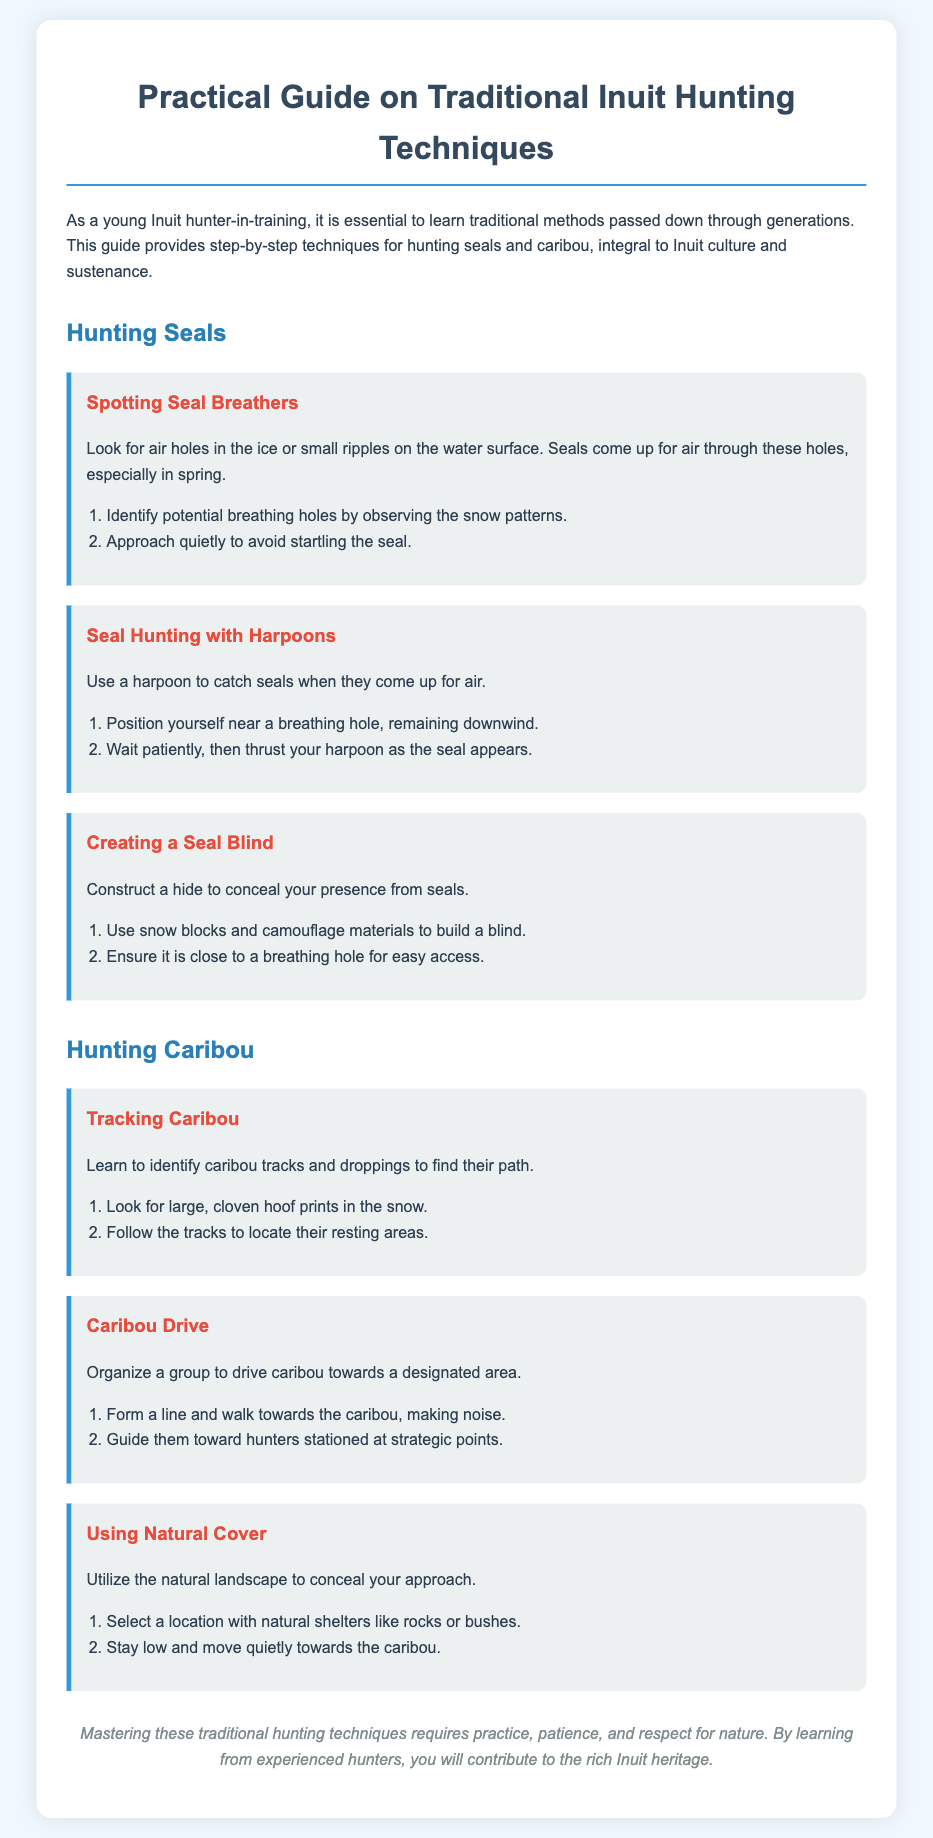What are the three techniques for hunting seals? The document lists three techniques: Spotting Seal Breathers, Seal Hunting with Harpoons, and Creating a Seal Blind.
Answer: Spotting Seal Breathers, Seal Hunting with Harpoons, Creating a Seal Blind How do you track caribou? To track caribou, one must look for large, cloven hoof prints in the snow and follow the tracks to locate their resting areas.
Answer: Look for large, cloven hoof prints What is used to catch seals when they come up for air? The document specifies that a harpoon is used to catch seals.
Answer: Harpoon What is the first step in creating a seal blind? The first step is to use snow blocks and camouflage materials to build a blind.
Answer: Use snow blocks and camouflage materials What is the main goal of the caribou drive technique? The main goal of the caribou drive technique is to organize a group to drive caribou toward a designated area.
Answer: Drive caribou toward a designated area What should you do when waiting for a seal to appear? One should wait patiently while positioned near a breathing hole.
Answer: Wait patiently What do you use as natural cover when hunting caribou? The document suggests selecting a location with natural shelters like rocks or bushes for natural cover.
Answer: Rocks or bushes 